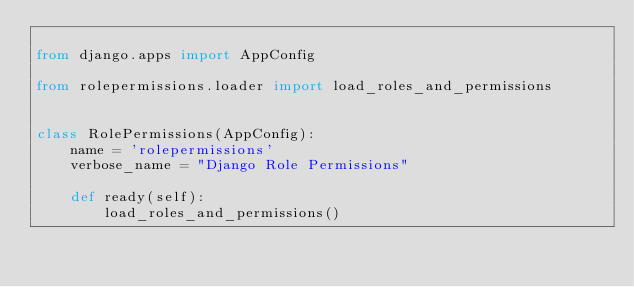Convert code to text. <code><loc_0><loc_0><loc_500><loc_500><_Python_>
from django.apps import AppConfig

from rolepermissions.loader import load_roles_and_permissions


class RolePermissions(AppConfig):
    name = 'rolepermissions'
    verbose_name = "Django Role Permissions"

    def ready(self):
        load_roles_and_permissions()
</code> 